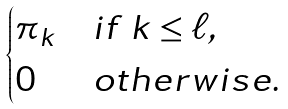<formula> <loc_0><loc_0><loc_500><loc_500>\begin{cases} \pi _ { k } & i f \ k \leq \ell , \\ 0 & o t h e r w i s e . \end{cases}</formula> 